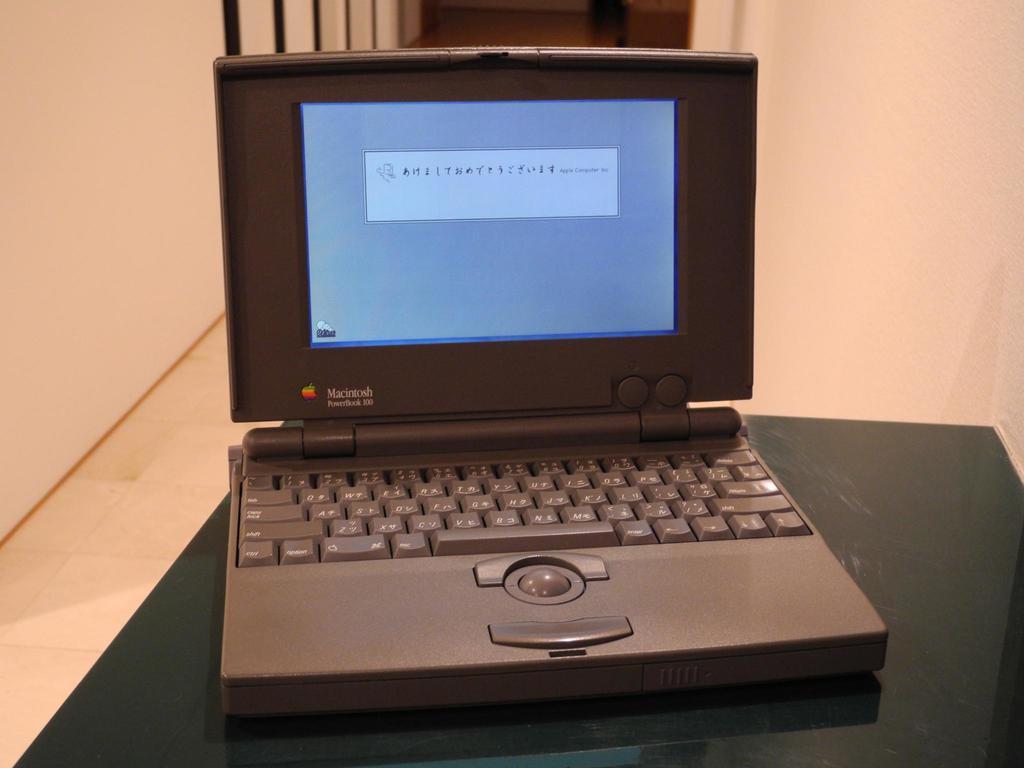Describe this image in one or two sentences. There is a table. On that there is a laptop. In the background there is a wall. 